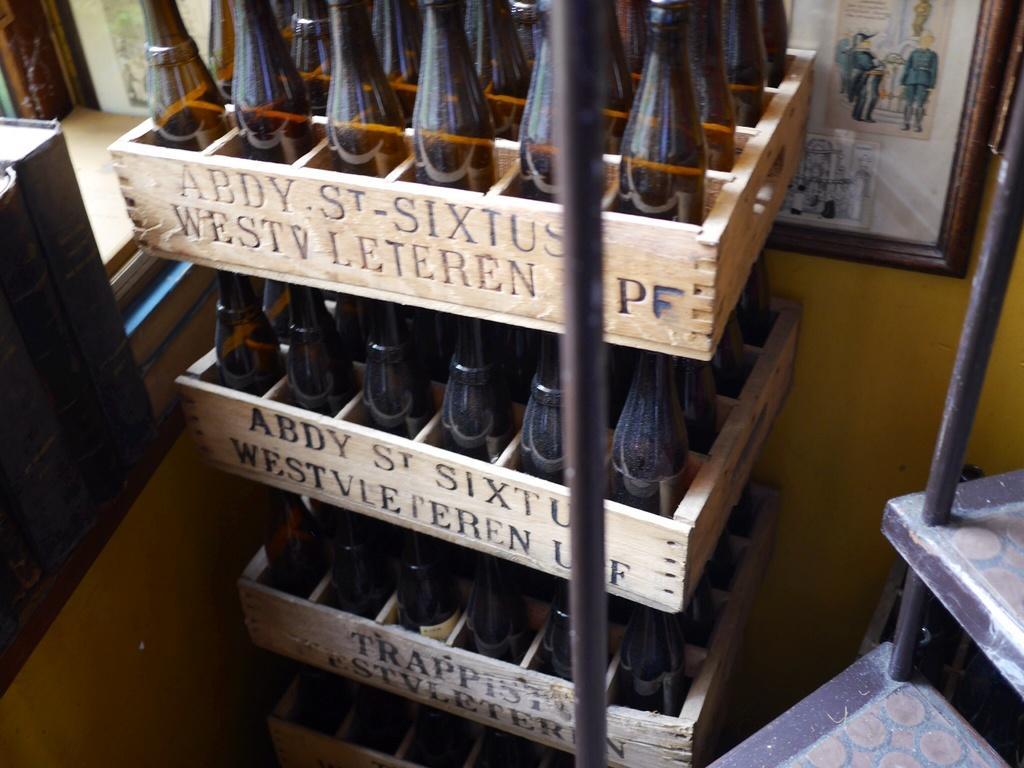Can you describe this image briefly? In the image there are wooden boxes with bottles in it. And also there is text on it. Behind the boxes on the wall there is a frame. On the right side of the image there are iron objects. On the left side of the image there are books on the rack. 